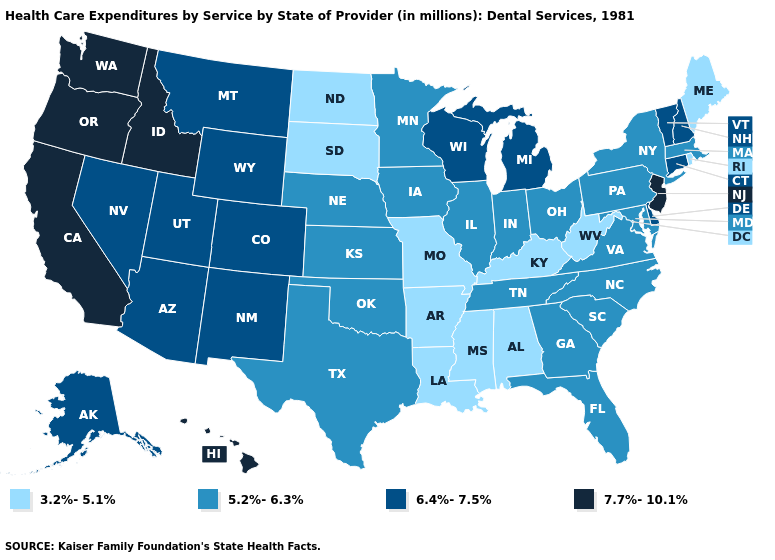Is the legend a continuous bar?
Quick response, please. No. Name the states that have a value in the range 6.4%-7.5%?
Concise answer only. Alaska, Arizona, Colorado, Connecticut, Delaware, Michigan, Montana, Nevada, New Hampshire, New Mexico, Utah, Vermont, Wisconsin, Wyoming. Does Wyoming have the highest value in the USA?
Write a very short answer. No. Does Florida have a higher value than Vermont?
Answer briefly. No. Name the states that have a value in the range 3.2%-5.1%?
Write a very short answer. Alabama, Arkansas, Kentucky, Louisiana, Maine, Mississippi, Missouri, North Dakota, Rhode Island, South Dakota, West Virginia. What is the highest value in the MidWest ?
Quick response, please. 6.4%-7.5%. Does the first symbol in the legend represent the smallest category?
Write a very short answer. Yes. Does West Virginia have a lower value than Alabama?
Answer briefly. No. How many symbols are there in the legend?
Concise answer only. 4. What is the value of Michigan?
Short answer required. 6.4%-7.5%. What is the value of Connecticut?
Be succinct. 6.4%-7.5%. What is the lowest value in the West?
Quick response, please. 6.4%-7.5%. Does Ohio have the lowest value in the MidWest?
Give a very brief answer. No. What is the value of Minnesota?
Answer briefly. 5.2%-6.3%. What is the lowest value in the Northeast?
Concise answer only. 3.2%-5.1%. 